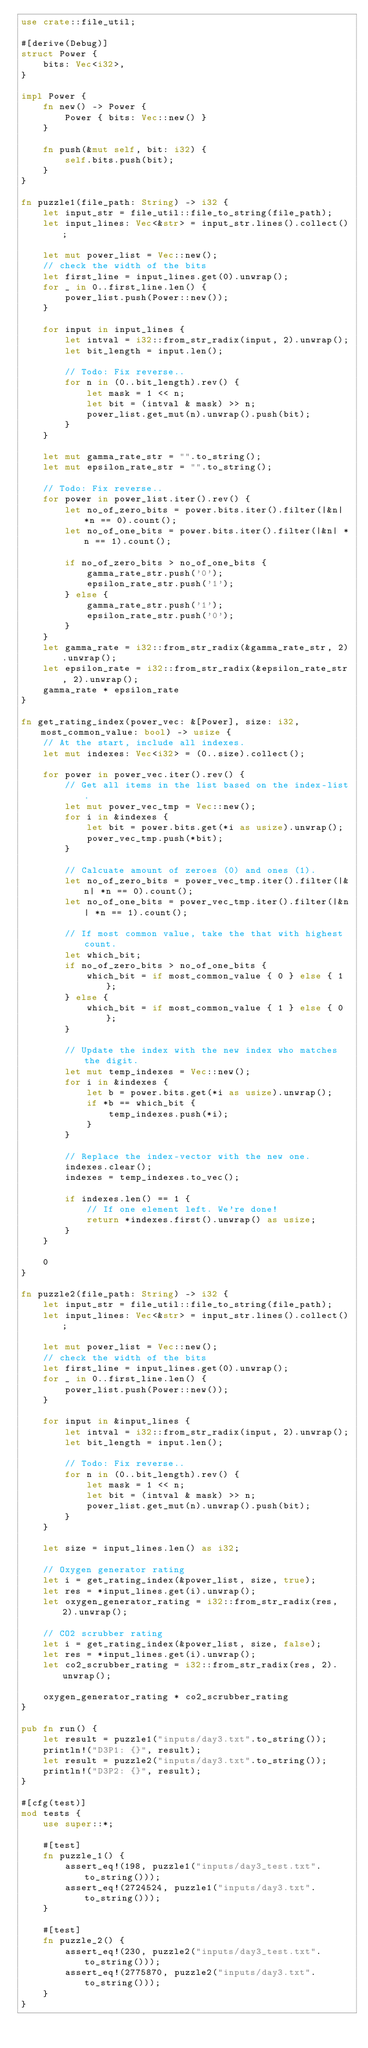<code> <loc_0><loc_0><loc_500><loc_500><_Rust_>use crate::file_util;

#[derive(Debug)]
struct Power {
    bits: Vec<i32>,
}

impl Power {
    fn new() -> Power {
        Power { bits: Vec::new() }
    }

    fn push(&mut self, bit: i32) {
        self.bits.push(bit);
    }
}

fn puzzle1(file_path: String) -> i32 {
    let input_str = file_util::file_to_string(file_path);
    let input_lines: Vec<&str> = input_str.lines().collect();

    let mut power_list = Vec::new();
    // check the width of the bits
    let first_line = input_lines.get(0).unwrap();
    for _ in 0..first_line.len() {
        power_list.push(Power::new());
    }

    for input in input_lines {
        let intval = i32::from_str_radix(input, 2).unwrap();
        let bit_length = input.len();

        // Todo: Fix reverse..
        for n in (0..bit_length).rev() {
            let mask = 1 << n;
            let bit = (intval & mask) >> n;
            power_list.get_mut(n).unwrap().push(bit);
        }
    }

    let mut gamma_rate_str = "".to_string();
    let mut epsilon_rate_str = "".to_string();

    // Todo: Fix reverse..
    for power in power_list.iter().rev() {
        let no_of_zero_bits = power.bits.iter().filter(|&n| *n == 0).count();
        let no_of_one_bits = power.bits.iter().filter(|&n| *n == 1).count();

        if no_of_zero_bits > no_of_one_bits {
            gamma_rate_str.push('0');
            epsilon_rate_str.push('1');
        } else {
            gamma_rate_str.push('1');
            epsilon_rate_str.push('0');
        }
    }
    let gamma_rate = i32::from_str_radix(&gamma_rate_str, 2).unwrap();
    let epsilon_rate = i32::from_str_radix(&epsilon_rate_str, 2).unwrap();
    gamma_rate * epsilon_rate
}

fn get_rating_index(power_vec: &[Power], size: i32, most_common_value: bool) -> usize {
    // At the start, include all indexes.
    let mut indexes: Vec<i32> = (0..size).collect();

    for power in power_vec.iter().rev() {
        // Get all items in the list based on the index-list.
        let mut power_vec_tmp = Vec::new();
        for i in &indexes {
            let bit = power.bits.get(*i as usize).unwrap();
            power_vec_tmp.push(*bit);
        }

        // Calcuate amount of zeroes (0) and ones (1).
        let no_of_zero_bits = power_vec_tmp.iter().filter(|&n| *n == 0).count();
        let no_of_one_bits = power_vec_tmp.iter().filter(|&n| *n == 1).count();

        // If most common value, take the that with highest count.
        let which_bit;
        if no_of_zero_bits > no_of_one_bits {
            which_bit = if most_common_value { 0 } else { 1 };
        } else {
            which_bit = if most_common_value { 1 } else { 0 };
        }

        // Update the index with the new index who matches the digit.
        let mut temp_indexes = Vec::new();
        for i in &indexes {
            let b = power.bits.get(*i as usize).unwrap();
            if *b == which_bit {
                temp_indexes.push(*i);
            }
        }

        // Replace the index-vector with the new one.
        indexes.clear();
        indexes = temp_indexes.to_vec();

        if indexes.len() == 1 {
            // If one element left. We're done!
            return *indexes.first().unwrap() as usize;
        }
    }

    0
}

fn puzzle2(file_path: String) -> i32 {
    let input_str = file_util::file_to_string(file_path);
    let input_lines: Vec<&str> = input_str.lines().collect();

    let mut power_list = Vec::new();
    // check the width of the bits
    let first_line = input_lines.get(0).unwrap();
    for _ in 0..first_line.len() {
        power_list.push(Power::new());
    }

    for input in &input_lines {
        let intval = i32::from_str_radix(input, 2).unwrap();
        let bit_length = input.len();

        // Todo: Fix reverse..
        for n in (0..bit_length).rev() {
            let mask = 1 << n;
            let bit = (intval & mask) >> n;
            power_list.get_mut(n).unwrap().push(bit);
        }
    }

    let size = input_lines.len() as i32;

    // Oxygen generator rating
    let i = get_rating_index(&power_list, size, true);
    let res = *input_lines.get(i).unwrap();
    let oxygen_generator_rating = i32::from_str_radix(res, 2).unwrap();

    // CO2 scrubber rating
    let i = get_rating_index(&power_list, size, false);
    let res = *input_lines.get(i).unwrap();
    let co2_scrubber_rating = i32::from_str_radix(res, 2).unwrap();

    oxygen_generator_rating * co2_scrubber_rating
}

pub fn run() {
    let result = puzzle1("inputs/day3.txt".to_string());
    println!("D3P1: {}", result);
    let result = puzzle2("inputs/day3.txt".to_string());
    println!("D3P2: {}", result);
}

#[cfg(test)]
mod tests {
    use super::*;

    #[test]
    fn puzzle_1() {
        assert_eq!(198, puzzle1("inputs/day3_test.txt".to_string()));
        assert_eq!(2724524, puzzle1("inputs/day3.txt".to_string()));
    }

    #[test]
    fn puzzle_2() {
        assert_eq!(230, puzzle2("inputs/day3_test.txt".to_string()));
        assert_eq!(2775870, puzzle2("inputs/day3.txt".to_string()));
    }
}
</code> 